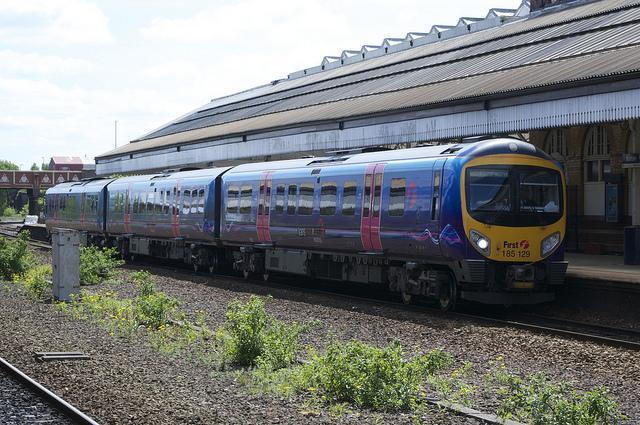How many feathers?
Give a very brief answer. 0. 